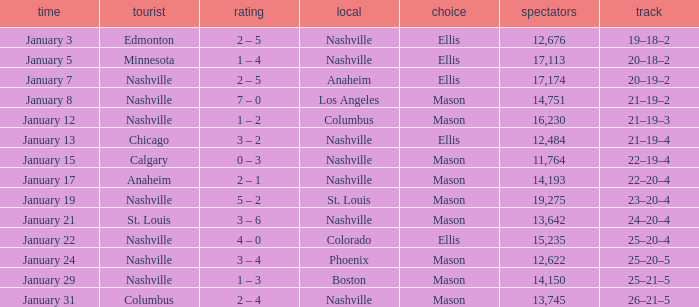On January 29, who had the decision of Mason? Nashville. Can you parse all the data within this table? {'header': ['time', 'tourist', 'rating', 'local', 'choice', 'spectators', 'track'], 'rows': [['January 3', 'Edmonton', '2 – 5', 'Nashville', 'Ellis', '12,676', '19–18–2'], ['January 5', 'Minnesota', '1 – 4', 'Nashville', 'Ellis', '17,113', '20–18–2'], ['January 7', 'Nashville', '2 – 5', 'Anaheim', 'Ellis', '17,174', '20–19–2'], ['January 8', 'Nashville', '7 – 0', 'Los Angeles', 'Mason', '14,751', '21–19–2'], ['January 12', 'Nashville', '1 – 2', 'Columbus', 'Mason', '16,230', '21–19–3'], ['January 13', 'Chicago', '3 – 2', 'Nashville', 'Ellis', '12,484', '21–19–4'], ['January 15', 'Calgary', '0 – 3', 'Nashville', 'Mason', '11,764', '22–19–4'], ['January 17', 'Anaheim', '2 – 1', 'Nashville', 'Mason', '14,193', '22–20–4'], ['January 19', 'Nashville', '5 – 2', 'St. Louis', 'Mason', '19,275', '23–20–4'], ['January 21', 'St. Louis', '3 – 6', 'Nashville', 'Mason', '13,642', '24–20–4'], ['January 22', 'Nashville', '4 – 0', 'Colorado', 'Ellis', '15,235', '25–20–4'], ['January 24', 'Nashville', '3 – 4', 'Phoenix', 'Mason', '12,622', '25–20–5'], ['January 29', 'Nashville', '1 – 3', 'Boston', 'Mason', '14,150', '25–21–5'], ['January 31', 'Columbus', '2 – 4', 'Nashville', 'Mason', '13,745', '26–21–5']]} 